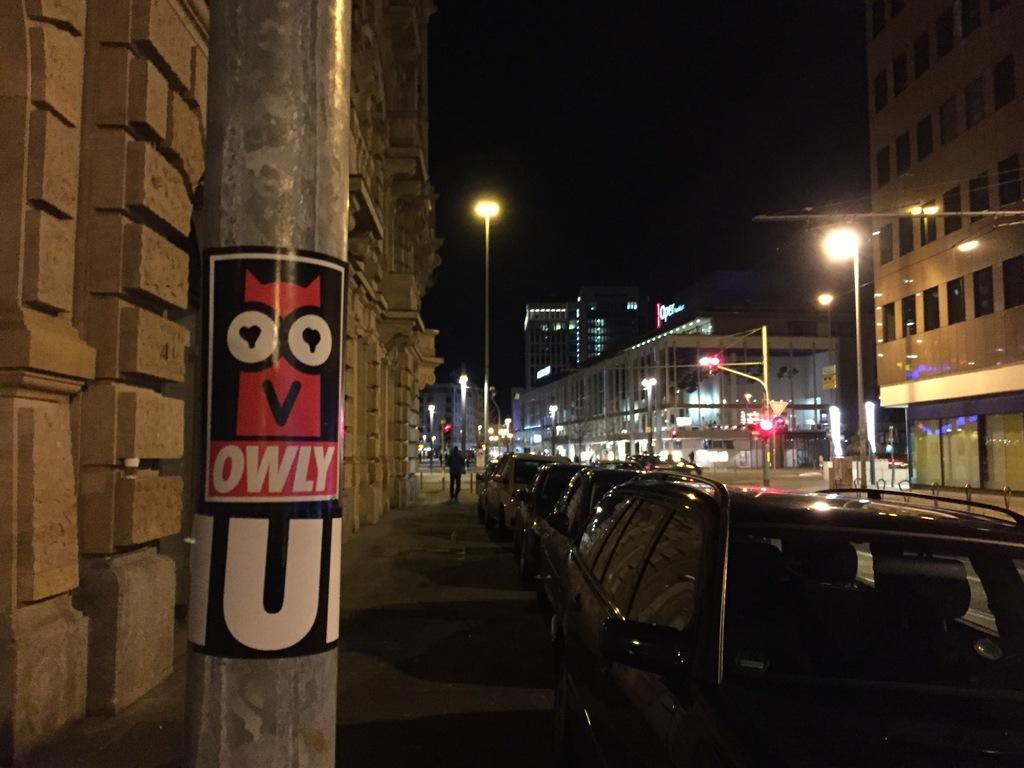Can you describe this image briefly? At the center of the image there are some vehicles which are parked in a side of a road. On the left side of the image there is a wall, in front of the wall there is a pole and one person is walking in the path of a road. On the right side of the image there are some buildings and utility poles. The background is dark. 